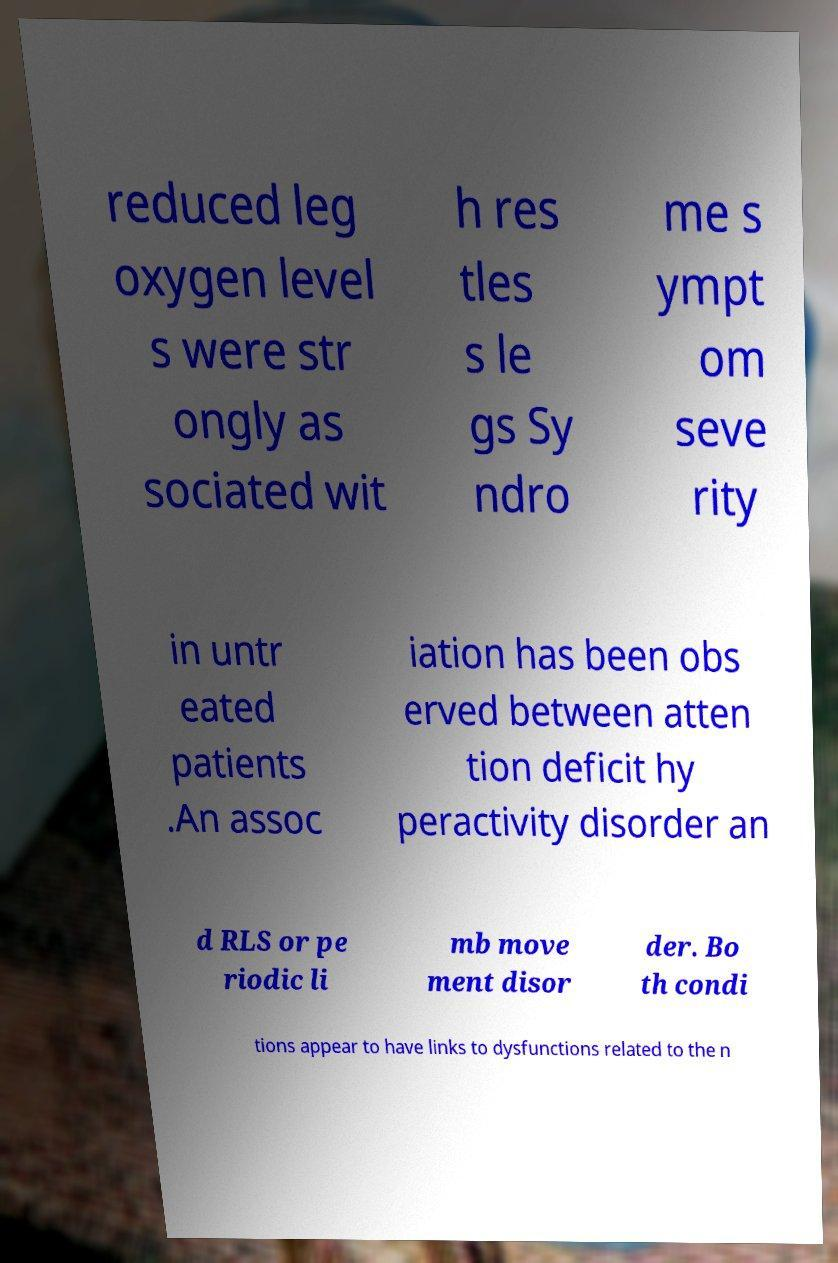I need the written content from this picture converted into text. Can you do that? reduced leg oxygen level s were str ongly as sociated wit h res tles s le gs Sy ndro me s ympt om seve rity in untr eated patients .An assoc iation has been obs erved between atten tion deficit hy peractivity disorder an d RLS or pe riodic li mb move ment disor der. Bo th condi tions appear to have links to dysfunctions related to the n 